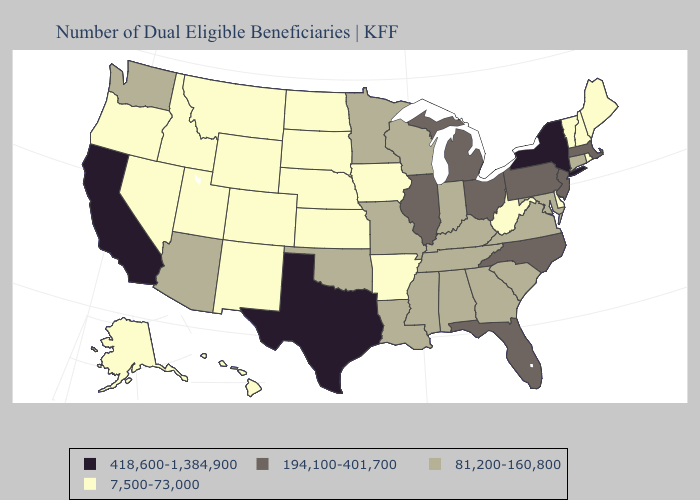What is the highest value in states that border Colorado?
Give a very brief answer. 81,200-160,800. Name the states that have a value in the range 418,600-1,384,900?
Short answer required. California, New York, Texas. Among the states that border Oklahoma , which have the lowest value?
Be succinct. Arkansas, Colorado, Kansas, New Mexico. Does New York have the highest value in the Northeast?
Concise answer only. Yes. What is the highest value in the USA?
Concise answer only. 418,600-1,384,900. Which states have the highest value in the USA?
Quick response, please. California, New York, Texas. Does Mississippi have the same value as North Dakota?
Be succinct. No. Among the states that border Maryland , does Virginia have the highest value?
Short answer required. No. Does the first symbol in the legend represent the smallest category?
Write a very short answer. No. Which states hav the highest value in the Northeast?
Answer briefly. New York. Name the states that have a value in the range 418,600-1,384,900?
Short answer required. California, New York, Texas. What is the value of Tennessee?
Short answer required. 81,200-160,800. Among the states that border Delaware , which have the lowest value?
Keep it brief. Maryland. Does West Virginia have the lowest value in the South?
Answer briefly. Yes. Which states have the lowest value in the Northeast?
Be succinct. Maine, New Hampshire, Rhode Island, Vermont. 